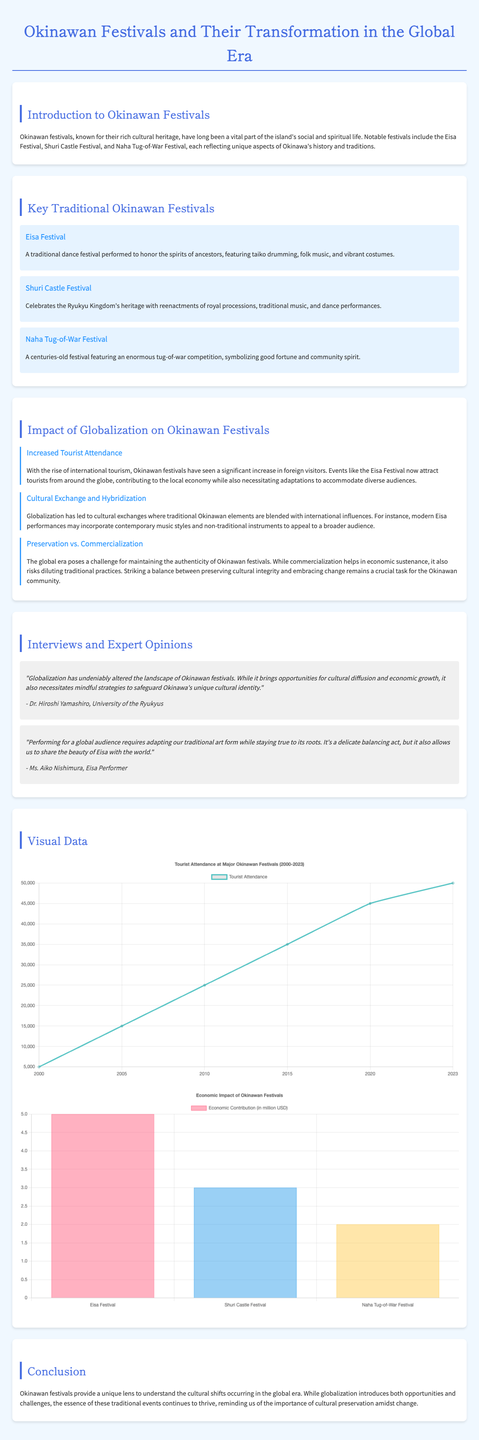what are the names of three key traditional Okinawan festivals? The document lists three key festivals: Eisa Festival, Shuri Castle Festival, and Naha Tug-of-War Festival.
Answer: Eisa Festival, Shuri Castle Festival, Naha Tug-of-War Festival who is an expert mentioned in the document? The document cites Dr. Hiroshi Yamashiro as an expert opinion regarding the impact of globalization on Okinawan festivals.
Answer: Dr. Hiroshi Yamashiro what year saw a tourist attendance of 15000 at Okinawan festivals? The document provides a chart indicating tourist attendance for the year 2005.
Answer: 2005 what is the economic contribution of the Eisa Festival? According to the economic impact chart in the document, the Eisa Festival contributes five million USD.
Answer: 5 million USD what challenge is mentioned regarding the preservation of Okinawan festivals? The document highlights a challenge of maintaining authenticity amidst globalization and commercialization.
Answer: Authenticity how has globalization affected Okinawan festivals according to the document? The document describes increased tourist attendance and cultural exchange as primary effects of globalization on Okinawan festivals.
Answer: Increased tourist attendance and cultural exchange what type of chart shows tourist attendance data? The document includes a line chart for presenting tourist attendance information at Okinawan festivals.
Answer: Line chart how many million USD is the economic contribution of the Naha Tug-of-War Festival? The document specifies that the Naha Tug-of-War Festival contributes two million USD to the economy.
Answer: 2 million USD 